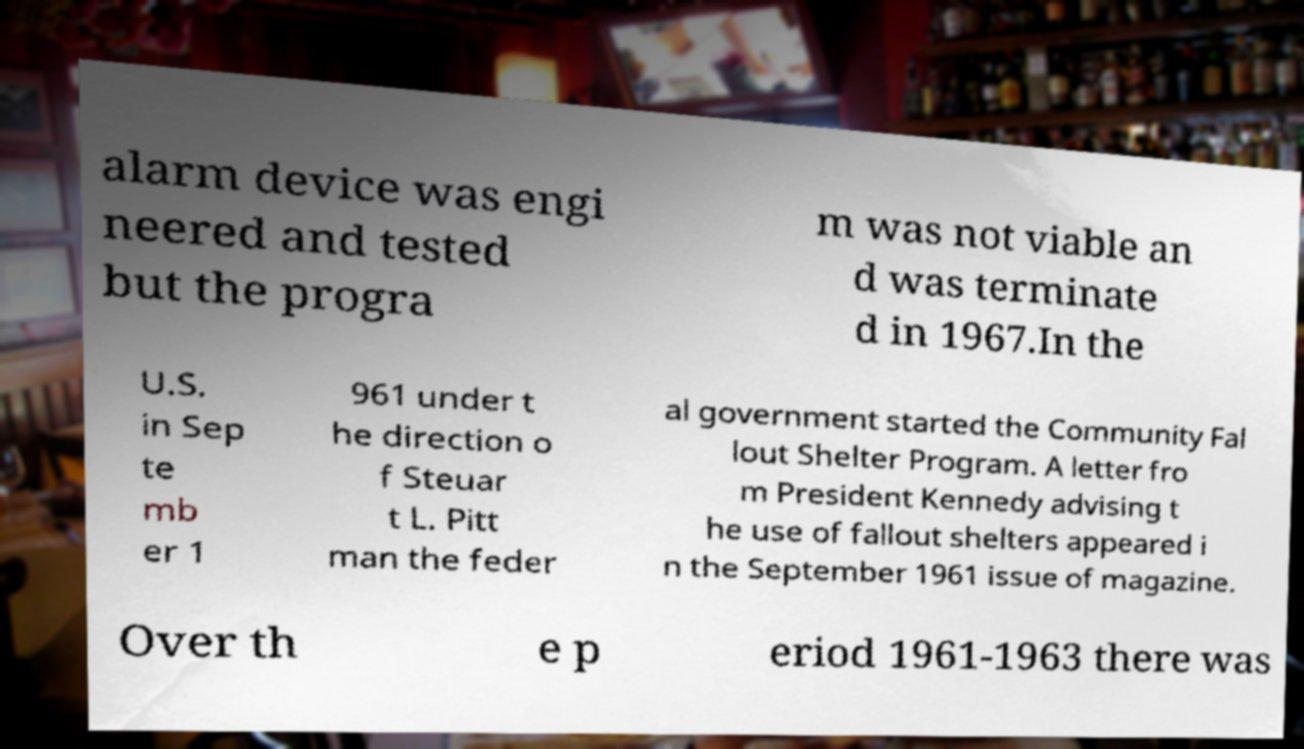Please identify and transcribe the text found in this image. alarm device was engi neered and tested but the progra m was not viable an d was terminate d in 1967.In the U.S. in Sep te mb er 1 961 under t he direction o f Steuar t L. Pitt man the feder al government started the Community Fal lout Shelter Program. A letter fro m President Kennedy advising t he use of fallout shelters appeared i n the September 1961 issue of magazine. Over th e p eriod 1961-1963 there was 